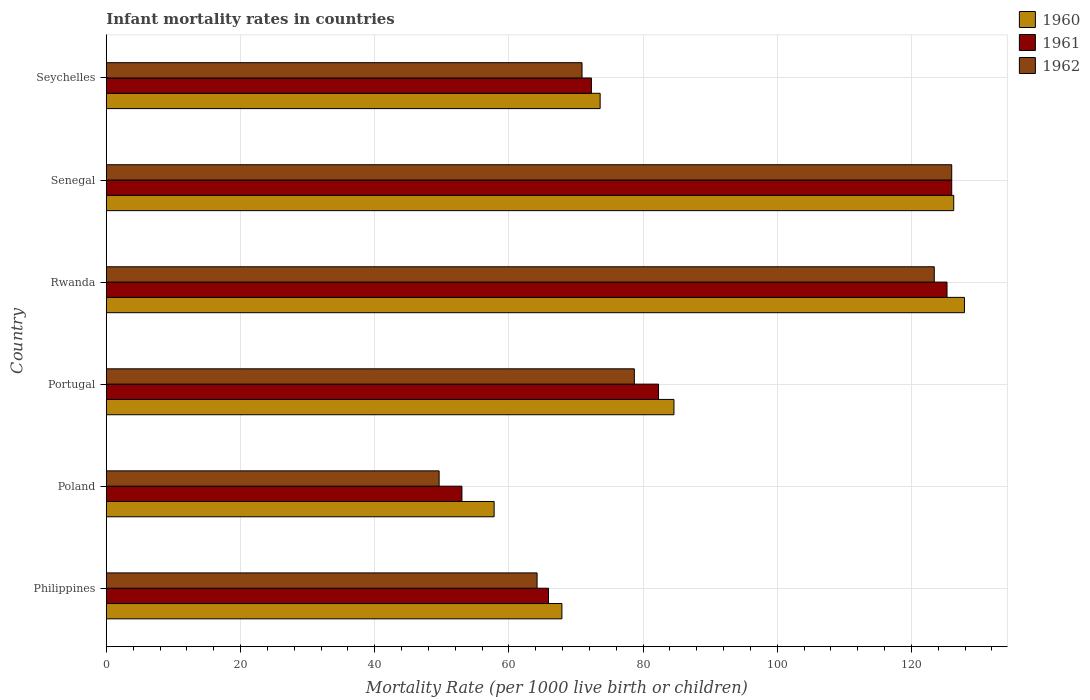How many different coloured bars are there?
Offer a terse response. 3. How many groups of bars are there?
Your response must be concise. 6. Are the number of bars on each tick of the Y-axis equal?
Your answer should be very brief. Yes. How many bars are there on the 2nd tick from the bottom?
Provide a short and direct response. 3. What is the label of the 2nd group of bars from the top?
Keep it short and to the point. Senegal. What is the infant mortality rate in 1960 in Philippines?
Provide a short and direct response. 67.9. Across all countries, what is the maximum infant mortality rate in 1961?
Give a very brief answer. 126. In which country was the infant mortality rate in 1961 maximum?
Ensure brevity in your answer.  Senegal. What is the total infant mortality rate in 1961 in the graph?
Your response must be concise. 524.8. What is the difference between the infant mortality rate in 1962 in Philippines and that in Seychelles?
Keep it short and to the point. -6.7. What is the difference between the infant mortality rate in 1961 in Poland and the infant mortality rate in 1960 in Portugal?
Your answer should be compact. -31.6. What is the average infant mortality rate in 1960 per country?
Ensure brevity in your answer.  89.68. What is the difference between the infant mortality rate in 1960 and infant mortality rate in 1962 in Senegal?
Your response must be concise. 0.3. What is the ratio of the infant mortality rate in 1960 in Poland to that in Senegal?
Provide a short and direct response. 0.46. Is the difference between the infant mortality rate in 1960 in Philippines and Seychelles greater than the difference between the infant mortality rate in 1962 in Philippines and Seychelles?
Give a very brief answer. Yes. What is the difference between the highest and the second highest infant mortality rate in 1961?
Make the answer very short. 0.7. What is the difference between the highest and the lowest infant mortality rate in 1962?
Your response must be concise. 76.4. Is the sum of the infant mortality rate in 1962 in Senegal and Seychelles greater than the maximum infant mortality rate in 1960 across all countries?
Offer a very short reply. Yes. What does the 2nd bar from the top in Poland represents?
Your answer should be compact. 1961. What does the 3rd bar from the bottom in Portugal represents?
Offer a terse response. 1962. Is it the case that in every country, the sum of the infant mortality rate in 1960 and infant mortality rate in 1961 is greater than the infant mortality rate in 1962?
Give a very brief answer. Yes. Are all the bars in the graph horizontal?
Your response must be concise. Yes. What is the difference between two consecutive major ticks on the X-axis?
Provide a succinct answer. 20. Does the graph contain grids?
Your answer should be very brief. Yes. Where does the legend appear in the graph?
Make the answer very short. Top right. How are the legend labels stacked?
Keep it short and to the point. Vertical. What is the title of the graph?
Offer a terse response. Infant mortality rates in countries. Does "2001" appear as one of the legend labels in the graph?
Offer a very short reply. No. What is the label or title of the X-axis?
Give a very brief answer. Mortality Rate (per 1000 live birth or children). What is the Mortality Rate (per 1000 live birth or children) in 1960 in Philippines?
Offer a very short reply. 67.9. What is the Mortality Rate (per 1000 live birth or children) in 1961 in Philippines?
Give a very brief answer. 65.9. What is the Mortality Rate (per 1000 live birth or children) in 1962 in Philippines?
Offer a very short reply. 64.2. What is the Mortality Rate (per 1000 live birth or children) in 1960 in Poland?
Your answer should be very brief. 57.8. What is the Mortality Rate (per 1000 live birth or children) in 1961 in Poland?
Provide a short and direct response. 53. What is the Mortality Rate (per 1000 live birth or children) of 1962 in Poland?
Provide a succinct answer. 49.6. What is the Mortality Rate (per 1000 live birth or children) in 1960 in Portugal?
Keep it short and to the point. 84.6. What is the Mortality Rate (per 1000 live birth or children) of 1961 in Portugal?
Your response must be concise. 82.3. What is the Mortality Rate (per 1000 live birth or children) of 1962 in Portugal?
Give a very brief answer. 78.7. What is the Mortality Rate (per 1000 live birth or children) in 1960 in Rwanda?
Ensure brevity in your answer.  127.9. What is the Mortality Rate (per 1000 live birth or children) of 1961 in Rwanda?
Your answer should be very brief. 125.3. What is the Mortality Rate (per 1000 live birth or children) in 1962 in Rwanda?
Offer a very short reply. 123.4. What is the Mortality Rate (per 1000 live birth or children) in 1960 in Senegal?
Ensure brevity in your answer.  126.3. What is the Mortality Rate (per 1000 live birth or children) in 1961 in Senegal?
Your response must be concise. 126. What is the Mortality Rate (per 1000 live birth or children) of 1962 in Senegal?
Provide a short and direct response. 126. What is the Mortality Rate (per 1000 live birth or children) of 1960 in Seychelles?
Offer a very short reply. 73.6. What is the Mortality Rate (per 1000 live birth or children) of 1961 in Seychelles?
Provide a short and direct response. 72.3. What is the Mortality Rate (per 1000 live birth or children) in 1962 in Seychelles?
Make the answer very short. 70.9. Across all countries, what is the maximum Mortality Rate (per 1000 live birth or children) in 1960?
Offer a very short reply. 127.9. Across all countries, what is the maximum Mortality Rate (per 1000 live birth or children) of 1961?
Your answer should be very brief. 126. Across all countries, what is the maximum Mortality Rate (per 1000 live birth or children) in 1962?
Make the answer very short. 126. Across all countries, what is the minimum Mortality Rate (per 1000 live birth or children) in 1960?
Give a very brief answer. 57.8. Across all countries, what is the minimum Mortality Rate (per 1000 live birth or children) of 1961?
Ensure brevity in your answer.  53. Across all countries, what is the minimum Mortality Rate (per 1000 live birth or children) in 1962?
Keep it short and to the point. 49.6. What is the total Mortality Rate (per 1000 live birth or children) in 1960 in the graph?
Your answer should be compact. 538.1. What is the total Mortality Rate (per 1000 live birth or children) of 1961 in the graph?
Ensure brevity in your answer.  524.8. What is the total Mortality Rate (per 1000 live birth or children) in 1962 in the graph?
Make the answer very short. 512.8. What is the difference between the Mortality Rate (per 1000 live birth or children) of 1961 in Philippines and that in Poland?
Offer a terse response. 12.9. What is the difference between the Mortality Rate (per 1000 live birth or children) in 1962 in Philippines and that in Poland?
Offer a very short reply. 14.6. What is the difference between the Mortality Rate (per 1000 live birth or children) of 1960 in Philippines and that in Portugal?
Make the answer very short. -16.7. What is the difference between the Mortality Rate (per 1000 live birth or children) in 1961 in Philippines and that in Portugal?
Make the answer very short. -16.4. What is the difference between the Mortality Rate (per 1000 live birth or children) of 1962 in Philippines and that in Portugal?
Your answer should be compact. -14.5. What is the difference between the Mortality Rate (per 1000 live birth or children) in 1960 in Philippines and that in Rwanda?
Give a very brief answer. -60. What is the difference between the Mortality Rate (per 1000 live birth or children) of 1961 in Philippines and that in Rwanda?
Give a very brief answer. -59.4. What is the difference between the Mortality Rate (per 1000 live birth or children) of 1962 in Philippines and that in Rwanda?
Ensure brevity in your answer.  -59.2. What is the difference between the Mortality Rate (per 1000 live birth or children) of 1960 in Philippines and that in Senegal?
Offer a terse response. -58.4. What is the difference between the Mortality Rate (per 1000 live birth or children) of 1961 in Philippines and that in Senegal?
Your answer should be very brief. -60.1. What is the difference between the Mortality Rate (per 1000 live birth or children) in 1962 in Philippines and that in Senegal?
Your answer should be compact. -61.8. What is the difference between the Mortality Rate (per 1000 live birth or children) in 1962 in Philippines and that in Seychelles?
Your response must be concise. -6.7. What is the difference between the Mortality Rate (per 1000 live birth or children) of 1960 in Poland and that in Portugal?
Offer a terse response. -26.8. What is the difference between the Mortality Rate (per 1000 live birth or children) of 1961 in Poland and that in Portugal?
Your answer should be compact. -29.3. What is the difference between the Mortality Rate (per 1000 live birth or children) in 1962 in Poland and that in Portugal?
Keep it short and to the point. -29.1. What is the difference between the Mortality Rate (per 1000 live birth or children) in 1960 in Poland and that in Rwanda?
Ensure brevity in your answer.  -70.1. What is the difference between the Mortality Rate (per 1000 live birth or children) in 1961 in Poland and that in Rwanda?
Make the answer very short. -72.3. What is the difference between the Mortality Rate (per 1000 live birth or children) of 1962 in Poland and that in Rwanda?
Offer a terse response. -73.8. What is the difference between the Mortality Rate (per 1000 live birth or children) of 1960 in Poland and that in Senegal?
Keep it short and to the point. -68.5. What is the difference between the Mortality Rate (per 1000 live birth or children) of 1961 in Poland and that in Senegal?
Ensure brevity in your answer.  -73. What is the difference between the Mortality Rate (per 1000 live birth or children) in 1962 in Poland and that in Senegal?
Your answer should be very brief. -76.4. What is the difference between the Mortality Rate (per 1000 live birth or children) in 1960 in Poland and that in Seychelles?
Offer a terse response. -15.8. What is the difference between the Mortality Rate (per 1000 live birth or children) in 1961 in Poland and that in Seychelles?
Your answer should be very brief. -19.3. What is the difference between the Mortality Rate (per 1000 live birth or children) in 1962 in Poland and that in Seychelles?
Offer a terse response. -21.3. What is the difference between the Mortality Rate (per 1000 live birth or children) in 1960 in Portugal and that in Rwanda?
Your answer should be very brief. -43.3. What is the difference between the Mortality Rate (per 1000 live birth or children) in 1961 in Portugal and that in Rwanda?
Your answer should be compact. -43. What is the difference between the Mortality Rate (per 1000 live birth or children) of 1962 in Portugal and that in Rwanda?
Provide a short and direct response. -44.7. What is the difference between the Mortality Rate (per 1000 live birth or children) in 1960 in Portugal and that in Senegal?
Offer a very short reply. -41.7. What is the difference between the Mortality Rate (per 1000 live birth or children) of 1961 in Portugal and that in Senegal?
Make the answer very short. -43.7. What is the difference between the Mortality Rate (per 1000 live birth or children) of 1962 in Portugal and that in Senegal?
Make the answer very short. -47.3. What is the difference between the Mortality Rate (per 1000 live birth or children) of 1960 in Portugal and that in Seychelles?
Offer a terse response. 11. What is the difference between the Mortality Rate (per 1000 live birth or children) of 1961 in Portugal and that in Seychelles?
Your response must be concise. 10. What is the difference between the Mortality Rate (per 1000 live birth or children) in 1962 in Portugal and that in Seychelles?
Provide a short and direct response. 7.8. What is the difference between the Mortality Rate (per 1000 live birth or children) of 1962 in Rwanda and that in Senegal?
Provide a short and direct response. -2.6. What is the difference between the Mortality Rate (per 1000 live birth or children) in 1960 in Rwanda and that in Seychelles?
Provide a short and direct response. 54.3. What is the difference between the Mortality Rate (per 1000 live birth or children) of 1961 in Rwanda and that in Seychelles?
Offer a very short reply. 53. What is the difference between the Mortality Rate (per 1000 live birth or children) of 1962 in Rwanda and that in Seychelles?
Offer a very short reply. 52.5. What is the difference between the Mortality Rate (per 1000 live birth or children) of 1960 in Senegal and that in Seychelles?
Provide a short and direct response. 52.7. What is the difference between the Mortality Rate (per 1000 live birth or children) of 1961 in Senegal and that in Seychelles?
Keep it short and to the point. 53.7. What is the difference between the Mortality Rate (per 1000 live birth or children) of 1962 in Senegal and that in Seychelles?
Keep it short and to the point. 55.1. What is the difference between the Mortality Rate (per 1000 live birth or children) in 1960 in Philippines and the Mortality Rate (per 1000 live birth or children) in 1961 in Poland?
Ensure brevity in your answer.  14.9. What is the difference between the Mortality Rate (per 1000 live birth or children) of 1960 in Philippines and the Mortality Rate (per 1000 live birth or children) of 1961 in Portugal?
Offer a very short reply. -14.4. What is the difference between the Mortality Rate (per 1000 live birth or children) of 1960 in Philippines and the Mortality Rate (per 1000 live birth or children) of 1961 in Rwanda?
Your response must be concise. -57.4. What is the difference between the Mortality Rate (per 1000 live birth or children) in 1960 in Philippines and the Mortality Rate (per 1000 live birth or children) in 1962 in Rwanda?
Make the answer very short. -55.5. What is the difference between the Mortality Rate (per 1000 live birth or children) in 1961 in Philippines and the Mortality Rate (per 1000 live birth or children) in 1962 in Rwanda?
Keep it short and to the point. -57.5. What is the difference between the Mortality Rate (per 1000 live birth or children) of 1960 in Philippines and the Mortality Rate (per 1000 live birth or children) of 1961 in Senegal?
Offer a terse response. -58.1. What is the difference between the Mortality Rate (per 1000 live birth or children) in 1960 in Philippines and the Mortality Rate (per 1000 live birth or children) in 1962 in Senegal?
Your answer should be compact. -58.1. What is the difference between the Mortality Rate (per 1000 live birth or children) in 1961 in Philippines and the Mortality Rate (per 1000 live birth or children) in 1962 in Senegal?
Your answer should be very brief. -60.1. What is the difference between the Mortality Rate (per 1000 live birth or children) of 1960 in Philippines and the Mortality Rate (per 1000 live birth or children) of 1961 in Seychelles?
Provide a succinct answer. -4.4. What is the difference between the Mortality Rate (per 1000 live birth or children) of 1960 in Poland and the Mortality Rate (per 1000 live birth or children) of 1961 in Portugal?
Ensure brevity in your answer.  -24.5. What is the difference between the Mortality Rate (per 1000 live birth or children) in 1960 in Poland and the Mortality Rate (per 1000 live birth or children) in 1962 in Portugal?
Provide a short and direct response. -20.9. What is the difference between the Mortality Rate (per 1000 live birth or children) of 1961 in Poland and the Mortality Rate (per 1000 live birth or children) of 1962 in Portugal?
Make the answer very short. -25.7. What is the difference between the Mortality Rate (per 1000 live birth or children) in 1960 in Poland and the Mortality Rate (per 1000 live birth or children) in 1961 in Rwanda?
Offer a terse response. -67.5. What is the difference between the Mortality Rate (per 1000 live birth or children) in 1960 in Poland and the Mortality Rate (per 1000 live birth or children) in 1962 in Rwanda?
Make the answer very short. -65.6. What is the difference between the Mortality Rate (per 1000 live birth or children) in 1961 in Poland and the Mortality Rate (per 1000 live birth or children) in 1962 in Rwanda?
Give a very brief answer. -70.4. What is the difference between the Mortality Rate (per 1000 live birth or children) of 1960 in Poland and the Mortality Rate (per 1000 live birth or children) of 1961 in Senegal?
Keep it short and to the point. -68.2. What is the difference between the Mortality Rate (per 1000 live birth or children) in 1960 in Poland and the Mortality Rate (per 1000 live birth or children) in 1962 in Senegal?
Your answer should be very brief. -68.2. What is the difference between the Mortality Rate (per 1000 live birth or children) of 1961 in Poland and the Mortality Rate (per 1000 live birth or children) of 1962 in Senegal?
Provide a short and direct response. -73. What is the difference between the Mortality Rate (per 1000 live birth or children) in 1960 in Poland and the Mortality Rate (per 1000 live birth or children) in 1961 in Seychelles?
Provide a short and direct response. -14.5. What is the difference between the Mortality Rate (per 1000 live birth or children) in 1961 in Poland and the Mortality Rate (per 1000 live birth or children) in 1962 in Seychelles?
Ensure brevity in your answer.  -17.9. What is the difference between the Mortality Rate (per 1000 live birth or children) in 1960 in Portugal and the Mortality Rate (per 1000 live birth or children) in 1961 in Rwanda?
Ensure brevity in your answer.  -40.7. What is the difference between the Mortality Rate (per 1000 live birth or children) of 1960 in Portugal and the Mortality Rate (per 1000 live birth or children) of 1962 in Rwanda?
Provide a succinct answer. -38.8. What is the difference between the Mortality Rate (per 1000 live birth or children) in 1961 in Portugal and the Mortality Rate (per 1000 live birth or children) in 1962 in Rwanda?
Your answer should be very brief. -41.1. What is the difference between the Mortality Rate (per 1000 live birth or children) of 1960 in Portugal and the Mortality Rate (per 1000 live birth or children) of 1961 in Senegal?
Keep it short and to the point. -41.4. What is the difference between the Mortality Rate (per 1000 live birth or children) of 1960 in Portugal and the Mortality Rate (per 1000 live birth or children) of 1962 in Senegal?
Your answer should be compact. -41.4. What is the difference between the Mortality Rate (per 1000 live birth or children) of 1961 in Portugal and the Mortality Rate (per 1000 live birth or children) of 1962 in Senegal?
Make the answer very short. -43.7. What is the difference between the Mortality Rate (per 1000 live birth or children) in 1960 in Portugal and the Mortality Rate (per 1000 live birth or children) in 1962 in Seychelles?
Your response must be concise. 13.7. What is the difference between the Mortality Rate (per 1000 live birth or children) of 1961 in Portugal and the Mortality Rate (per 1000 live birth or children) of 1962 in Seychelles?
Your answer should be compact. 11.4. What is the difference between the Mortality Rate (per 1000 live birth or children) of 1961 in Rwanda and the Mortality Rate (per 1000 live birth or children) of 1962 in Senegal?
Keep it short and to the point. -0.7. What is the difference between the Mortality Rate (per 1000 live birth or children) of 1960 in Rwanda and the Mortality Rate (per 1000 live birth or children) of 1961 in Seychelles?
Your response must be concise. 55.6. What is the difference between the Mortality Rate (per 1000 live birth or children) of 1961 in Rwanda and the Mortality Rate (per 1000 live birth or children) of 1962 in Seychelles?
Ensure brevity in your answer.  54.4. What is the difference between the Mortality Rate (per 1000 live birth or children) of 1960 in Senegal and the Mortality Rate (per 1000 live birth or children) of 1961 in Seychelles?
Offer a very short reply. 54. What is the difference between the Mortality Rate (per 1000 live birth or children) of 1960 in Senegal and the Mortality Rate (per 1000 live birth or children) of 1962 in Seychelles?
Keep it short and to the point. 55.4. What is the difference between the Mortality Rate (per 1000 live birth or children) in 1961 in Senegal and the Mortality Rate (per 1000 live birth or children) in 1962 in Seychelles?
Offer a very short reply. 55.1. What is the average Mortality Rate (per 1000 live birth or children) in 1960 per country?
Keep it short and to the point. 89.68. What is the average Mortality Rate (per 1000 live birth or children) in 1961 per country?
Give a very brief answer. 87.47. What is the average Mortality Rate (per 1000 live birth or children) in 1962 per country?
Your answer should be very brief. 85.47. What is the difference between the Mortality Rate (per 1000 live birth or children) in 1960 and Mortality Rate (per 1000 live birth or children) in 1961 in Philippines?
Provide a short and direct response. 2. What is the difference between the Mortality Rate (per 1000 live birth or children) of 1961 and Mortality Rate (per 1000 live birth or children) of 1962 in Philippines?
Provide a succinct answer. 1.7. What is the difference between the Mortality Rate (per 1000 live birth or children) of 1960 and Mortality Rate (per 1000 live birth or children) of 1962 in Portugal?
Your answer should be very brief. 5.9. What is the difference between the Mortality Rate (per 1000 live birth or children) of 1960 and Mortality Rate (per 1000 live birth or children) of 1962 in Rwanda?
Your answer should be very brief. 4.5. What is the difference between the Mortality Rate (per 1000 live birth or children) in 1960 and Mortality Rate (per 1000 live birth or children) in 1961 in Senegal?
Offer a terse response. 0.3. What is the difference between the Mortality Rate (per 1000 live birth or children) in 1960 and Mortality Rate (per 1000 live birth or children) in 1962 in Senegal?
Your answer should be compact. 0.3. What is the difference between the Mortality Rate (per 1000 live birth or children) of 1961 and Mortality Rate (per 1000 live birth or children) of 1962 in Seychelles?
Your response must be concise. 1.4. What is the ratio of the Mortality Rate (per 1000 live birth or children) in 1960 in Philippines to that in Poland?
Give a very brief answer. 1.17. What is the ratio of the Mortality Rate (per 1000 live birth or children) in 1961 in Philippines to that in Poland?
Offer a terse response. 1.24. What is the ratio of the Mortality Rate (per 1000 live birth or children) in 1962 in Philippines to that in Poland?
Your answer should be compact. 1.29. What is the ratio of the Mortality Rate (per 1000 live birth or children) of 1960 in Philippines to that in Portugal?
Give a very brief answer. 0.8. What is the ratio of the Mortality Rate (per 1000 live birth or children) of 1961 in Philippines to that in Portugal?
Your response must be concise. 0.8. What is the ratio of the Mortality Rate (per 1000 live birth or children) in 1962 in Philippines to that in Portugal?
Your response must be concise. 0.82. What is the ratio of the Mortality Rate (per 1000 live birth or children) of 1960 in Philippines to that in Rwanda?
Provide a succinct answer. 0.53. What is the ratio of the Mortality Rate (per 1000 live birth or children) of 1961 in Philippines to that in Rwanda?
Make the answer very short. 0.53. What is the ratio of the Mortality Rate (per 1000 live birth or children) of 1962 in Philippines to that in Rwanda?
Your response must be concise. 0.52. What is the ratio of the Mortality Rate (per 1000 live birth or children) in 1960 in Philippines to that in Senegal?
Provide a succinct answer. 0.54. What is the ratio of the Mortality Rate (per 1000 live birth or children) of 1961 in Philippines to that in Senegal?
Offer a very short reply. 0.52. What is the ratio of the Mortality Rate (per 1000 live birth or children) of 1962 in Philippines to that in Senegal?
Give a very brief answer. 0.51. What is the ratio of the Mortality Rate (per 1000 live birth or children) in 1960 in Philippines to that in Seychelles?
Your answer should be very brief. 0.92. What is the ratio of the Mortality Rate (per 1000 live birth or children) in 1961 in Philippines to that in Seychelles?
Give a very brief answer. 0.91. What is the ratio of the Mortality Rate (per 1000 live birth or children) in 1962 in Philippines to that in Seychelles?
Provide a succinct answer. 0.91. What is the ratio of the Mortality Rate (per 1000 live birth or children) in 1960 in Poland to that in Portugal?
Keep it short and to the point. 0.68. What is the ratio of the Mortality Rate (per 1000 live birth or children) of 1961 in Poland to that in Portugal?
Your response must be concise. 0.64. What is the ratio of the Mortality Rate (per 1000 live birth or children) of 1962 in Poland to that in Portugal?
Provide a short and direct response. 0.63. What is the ratio of the Mortality Rate (per 1000 live birth or children) in 1960 in Poland to that in Rwanda?
Ensure brevity in your answer.  0.45. What is the ratio of the Mortality Rate (per 1000 live birth or children) of 1961 in Poland to that in Rwanda?
Ensure brevity in your answer.  0.42. What is the ratio of the Mortality Rate (per 1000 live birth or children) in 1962 in Poland to that in Rwanda?
Your answer should be very brief. 0.4. What is the ratio of the Mortality Rate (per 1000 live birth or children) in 1960 in Poland to that in Senegal?
Keep it short and to the point. 0.46. What is the ratio of the Mortality Rate (per 1000 live birth or children) in 1961 in Poland to that in Senegal?
Provide a short and direct response. 0.42. What is the ratio of the Mortality Rate (per 1000 live birth or children) in 1962 in Poland to that in Senegal?
Offer a very short reply. 0.39. What is the ratio of the Mortality Rate (per 1000 live birth or children) in 1960 in Poland to that in Seychelles?
Provide a short and direct response. 0.79. What is the ratio of the Mortality Rate (per 1000 live birth or children) in 1961 in Poland to that in Seychelles?
Make the answer very short. 0.73. What is the ratio of the Mortality Rate (per 1000 live birth or children) of 1962 in Poland to that in Seychelles?
Provide a succinct answer. 0.7. What is the ratio of the Mortality Rate (per 1000 live birth or children) of 1960 in Portugal to that in Rwanda?
Give a very brief answer. 0.66. What is the ratio of the Mortality Rate (per 1000 live birth or children) of 1961 in Portugal to that in Rwanda?
Offer a very short reply. 0.66. What is the ratio of the Mortality Rate (per 1000 live birth or children) of 1962 in Portugal to that in Rwanda?
Your response must be concise. 0.64. What is the ratio of the Mortality Rate (per 1000 live birth or children) of 1960 in Portugal to that in Senegal?
Provide a succinct answer. 0.67. What is the ratio of the Mortality Rate (per 1000 live birth or children) of 1961 in Portugal to that in Senegal?
Offer a very short reply. 0.65. What is the ratio of the Mortality Rate (per 1000 live birth or children) of 1962 in Portugal to that in Senegal?
Provide a short and direct response. 0.62. What is the ratio of the Mortality Rate (per 1000 live birth or children) of 1960 in Portugal to that in Seychelles?
Your answer should be very brief. 1.15. What is the ratio of the Mortality Rate (per 1000 live birth or children) of 1961 in Portugal to that in Seychelles?
Keep it short and to the point. 1.14. What is the ratio of the Mortality Rate (per 1000 live birth or children) in 1962 in Portugal to that in Seychelles?
Give a very brief answer. 1.11. What is the ratio of the Mortality Rate (per 1000 live birth or children) of 1960 in Rwanda to that in Senegal?
Offer a terse response. 1.01. What is the ratio of the Mortality Rate (per 1000 live birth or children) in 1961 in Rwanda to that in Senegal?
Offer a very short reply. 0.99. What is the ratio of the Mortality Rate (per 1000 live birth or children) in 1962 in Rwanda to that in Senegal?
Your response must be concise. 0.98. What is the ratio of the Mortality Rate (per 1000 live birth or children) in 1960 in Rwanda to that in Seychelles?
Give a very brief answer. 1.74. What is the ratio of the Mortality Rate (per 1000 live birth or children) in 1961 in Rwanda to that in Seychelles?
Provide a succinct answer. 1.73. What is the ratio of the Mortality Rate (per 1000 live birth or children) of 1962 in Rwanda to that in Seychelles?
Ensure brevity in your answer.  1.74. What is the ratio of the Mortality Rate (per 1000 live birth or children) of 1960 in Senegal to that in Seychelles?
Make the answer very short. 1.72. What is the ratio of the Mortality Rate (per 1000 live birth or children) of 1961 in Senegal to that in Seychelles?
Provide a short and direct response. 1.74. What is the ratio of the Mortality Rate (per 1000 live birth or children) in 1962 in Senegal to that in Seychelles?
Your answer should be compact. 1.78. What is the difference between the highest and the second highest Mortality Rate (per 1000 live birth or children) of 1960?
Ensure brevity in your answer.  1.6. What is the difference between the highest and the lowest Mortality Rate (per 1000 live birth or children) in 1960?
Give a very brief answer. 70.1. What is the difference between the highest and the lowest Mortality Rate (per 1000 live birth or children) of 1962?
Make the answer very short. 76.4. 